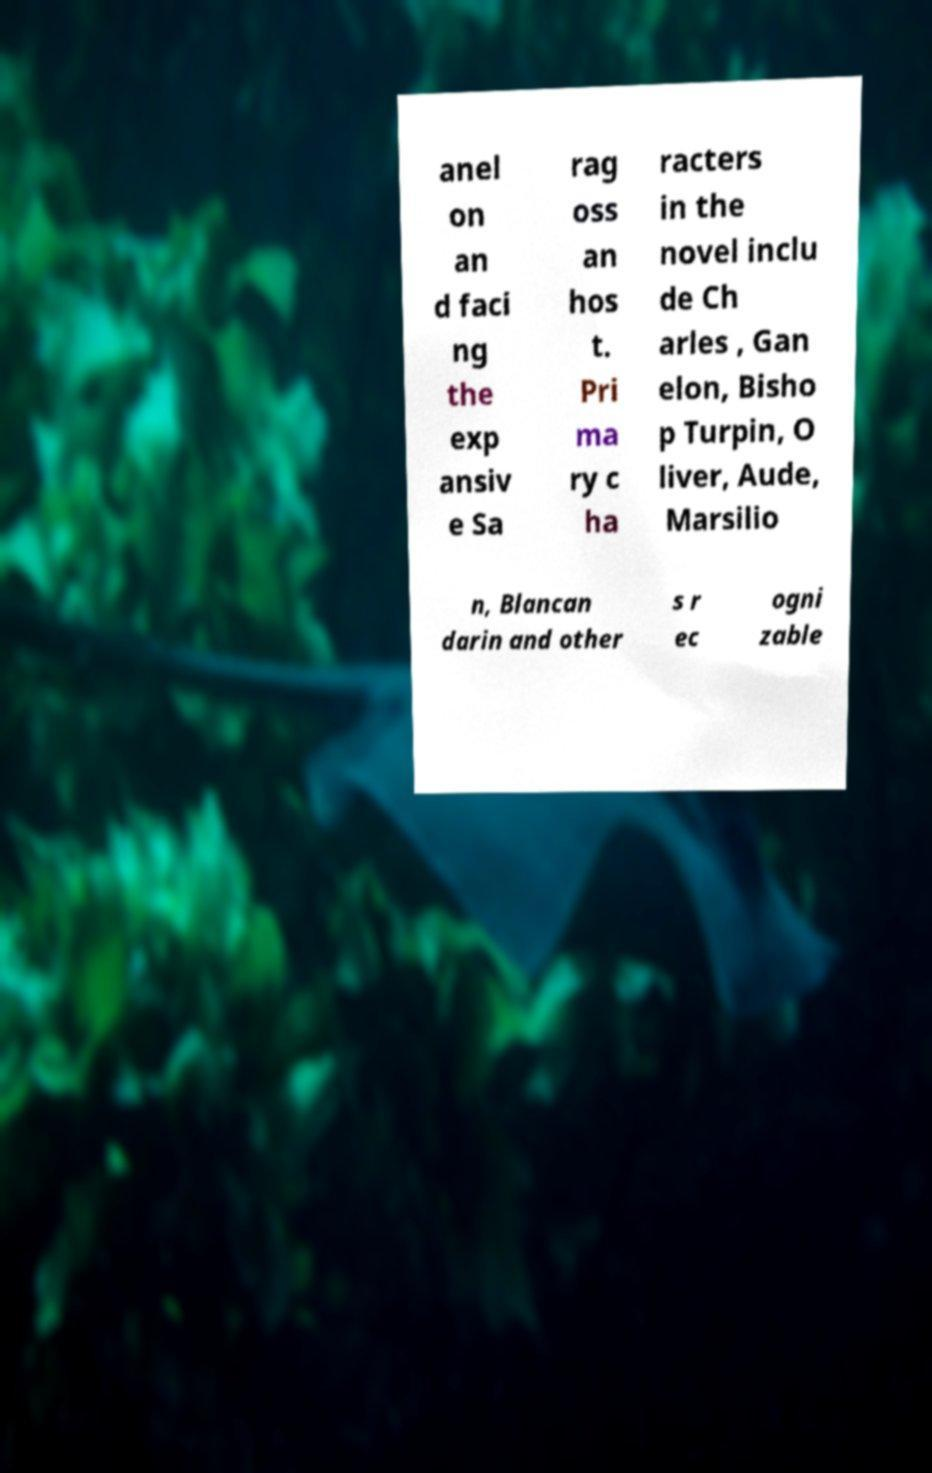There's text embedded in this image that I need extracted. Can you transcribe it verbatim? anel on an d faci ng the exp ansiv e Sa rag oss an hos t. Pri ma ry c ha racters in the novel inclu de Ch arles , Gan elon, Bisho p Turpin, O liver, Aude, Marsilio n, Blancan darin and other s r ec ogni zable 